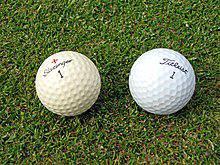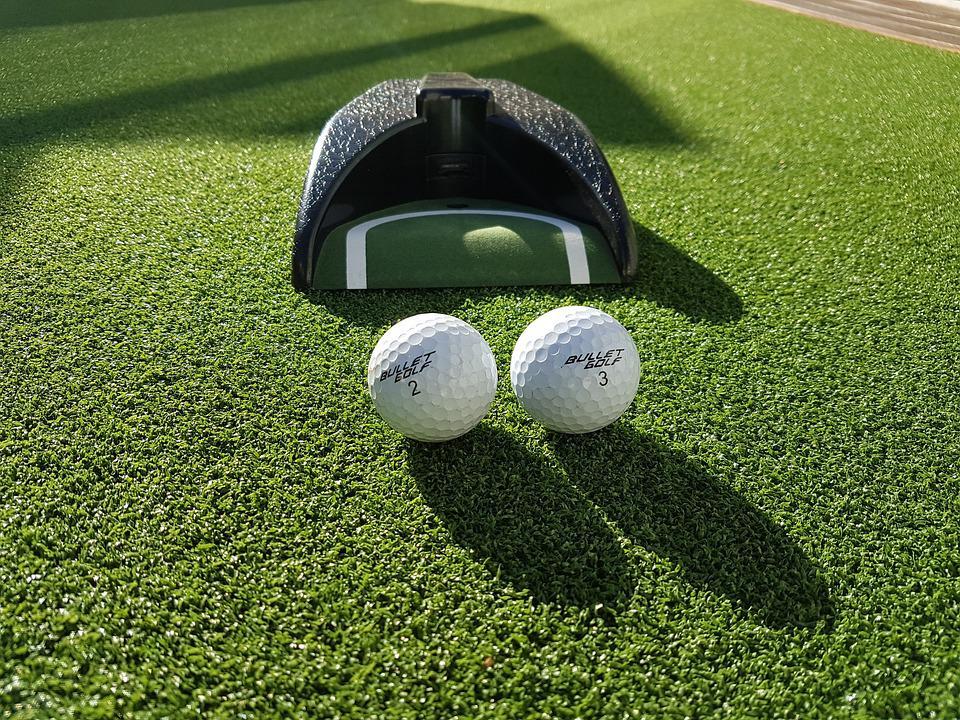The first image is the image on the left, the second image is the image on the right. Considering the images on both sides, is "There is one golf ball resting next to a hole in the image on the right" valid? Answer yes or no. No. 